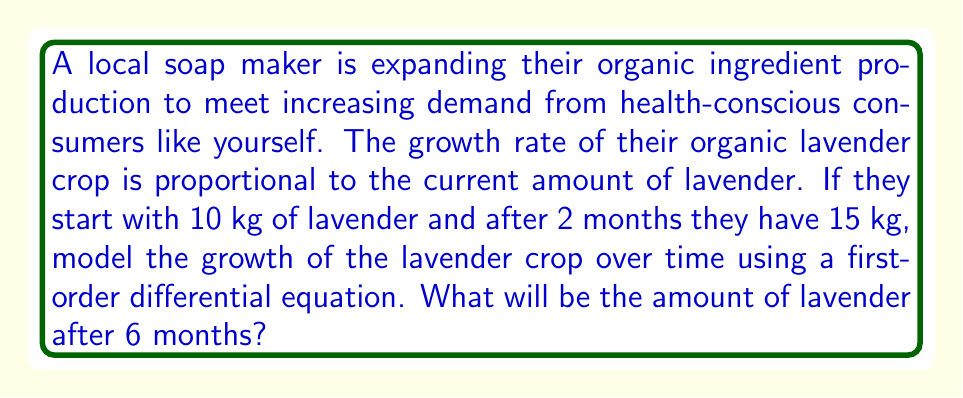Show me your answer to this math problem. Let's approach this step-by-step:

1) Let $L(t)$ be the amount of lavender (in kg) at time $t$ (in months).

2) The growth rate is proportional to the current amount, so we can write:

   $$\frac{dL}{dt} = kL$$

   where $k$ is the growth constant.

3) This is a separable differential equation. We can solve it as follows:

   $$\int \frac{dL}{L} = \int k dt$$
   $$\ln|L| = kt + C$$
   $$L = Ae^{kt}$$

   where $A = e^C$ is a constant.

4) We're given two points: 
   At $t=0$, $L=10$
   At $t=2$, $L=15$

5) Using the initial condition:
   $$10 = Ae^{k(0)}$$
   $$A = 10$$

6) Now we can find $k$ using the second point:
   $$15 = 10e^{2k}$$
   $$\frac{3}{2} = e^{2k}$$
   $$\ln(\frac{3}{2}) = 2k$$
   $$k = \frac{\ln(\frac{3}{2})}{2} \approx 0.2027$$

7) Our model is therefore:
   $$L(t) = 10e^{0.2027t}$$

8) To find the amount after 6 months, we substitute $t=6$:
   $$L(6) = 10e^{0.2027(6)} \approx 33.1$$
Answer: After 6 months, there will be approximately 33.1 kg of lavender. 